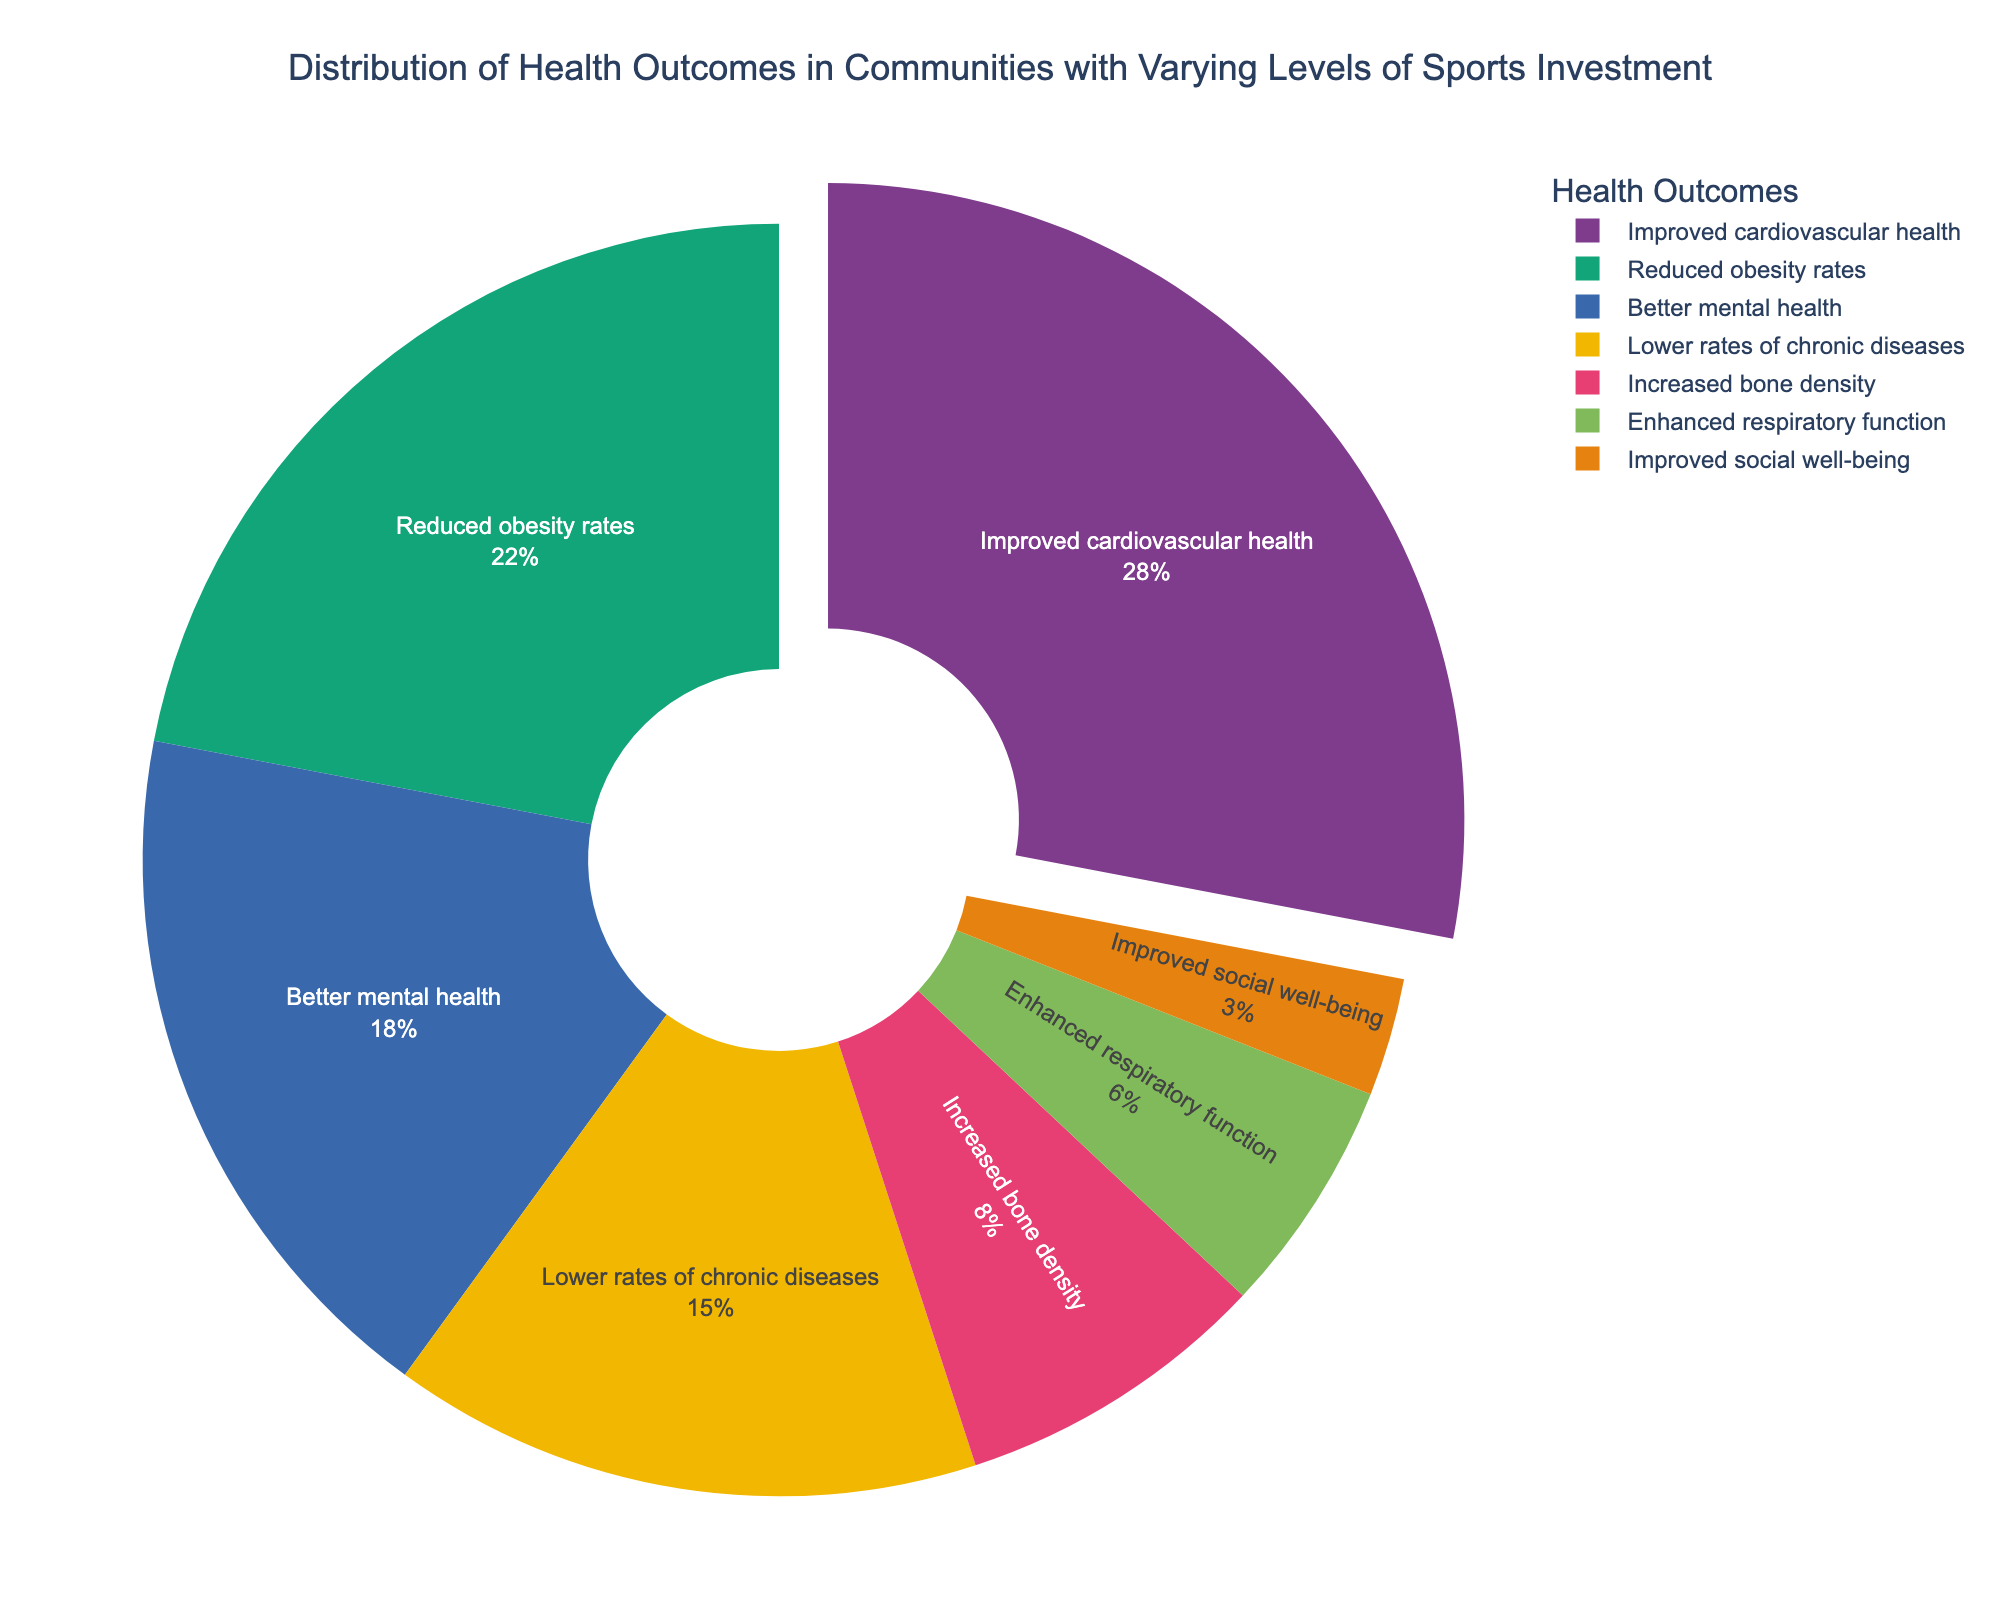What percentage of the health outcomes is attributed to improved cardiovascular health? The pie chart shows the percentage distribution for each health outcome. According to the chart, improved cardiovascular health accounts for 28% of the total health outcomes.
Answer: 28% Which health outcome category has the lowest percentage, and what is that percentage? By examining the segments of the pie chart, we see that "Improved social well-being" has the smallest segment. This category accounts for 3% of the total health outcomes.
Answer: Improved social well-being, 3% How much more does reduced obesity rates contribute to health outcomes compared to increased bone density? From the pie chart, reduced obesity rates account for 22%, while increased bone density accounts for 8%. To find the difference, subtract 8% from 22%. Therefore, reduced obesity rates contribute 14% more.
Answer: 14% What is the combined percentage of improved cardiovascular health and lower rates of chronic diseases? From the chart, improved cardiovascular health is 28% and lower rates of chronic diseases is 15%. Adding these together gives 28% + 15% = 43%.
Answer: 43% Which health outcome is represented by the segment pulled out slightly from the pie chart, and why is it pulled out? The pie chart highlights improved cardiovascular health by slightly pulling its segment out. This visual technique emphasizes its importance or proportion compared to other categories.
Answer: Improved cardiovascular health Compare the proportion of better mental health to enhanced respiratory function in terms of their respective percentages. Better mental health accounts for 18%, while enhanced respiratory function represents 6%. Better mental health is three times larger than enhanced respiratory function (18% / 6% = 3).
Answer: Better mental health is three times larger If you combine the percentages of lower rates of chronic diseases and improved social well-being, how does this compare to improved cardiovascular health? The pie chart provides 15% for lower rates of chronic diseases and 3% for improved social well-being. Combined, this is 15% + 3% = 18%. Compared to the 28% of improved cardiovascular health, the combination is 10% less.
Answer: 10% less What is the proportion of health outcomes related to improved cardiovascular health, reduced obesity rates, and better mental health combined? The percentages are 28%, 22%, and 18% for improved cardiovascular health, reduced obesity rates, and better mental health, respectively. Summing these gives 28% + 22% + 18% = 68%.
Answer: 68% Identify the health outcome category that accounts for a greater percentage than increased bone density but less than better mental health. From the pie chart, increased bone density is 8%, and better mental health is 18%. Reduced obesity rates fall between these values at 22%.
Answer: Reduced obesity rates 